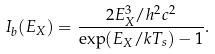<formula> <loc_0><loc_0><loc_500><loc_500>I _ { b } ( E _ { X } ) = \frac { 2 E _ { X } ^ { 3 } / h ^ { 2 } c ^ { 2 } } { \exp ( E _ { X } / k T _ { s } ) - 1 } .</formula> 